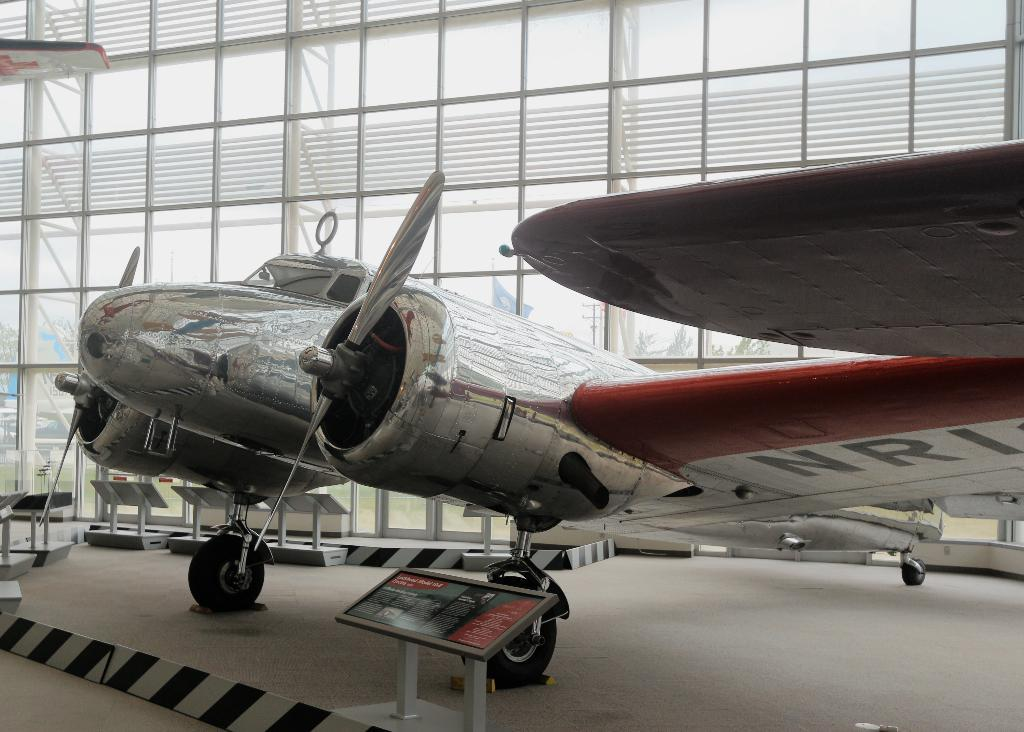<image>
Describe the image concisely. A sliver chrome airplane inside a building with the letters NRI cut off on a wing. 